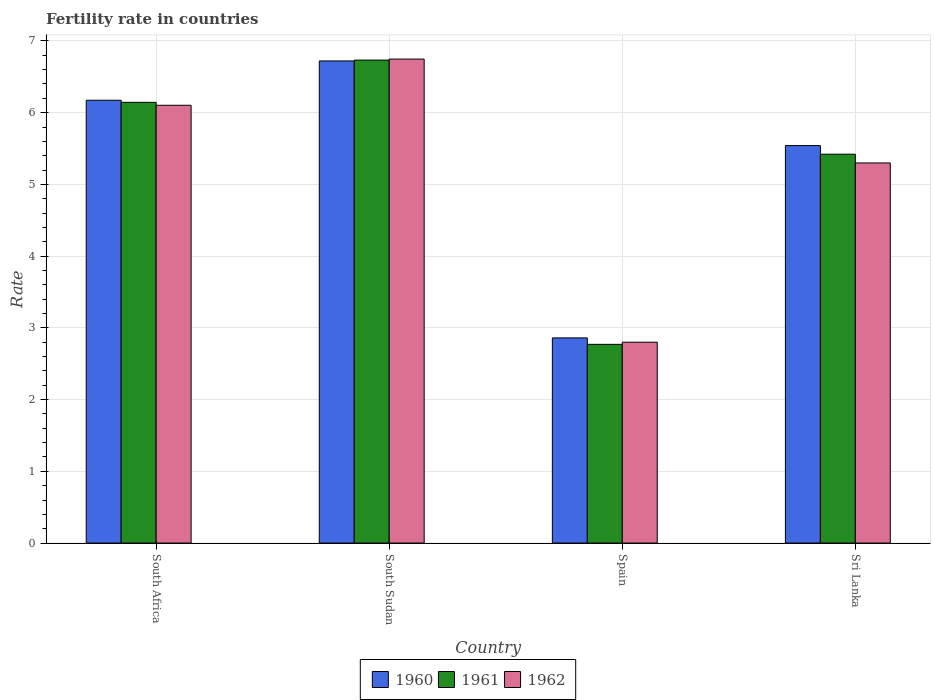How many groups of bars are there?
Keep it short and to the point. 4. Are the number of bars on each tick of the X-axis equal?
Your answer should be very brief. Yes. How many bars are there on the 4th tick from the left?
Keep it short and to the point. 3. How many bars are there on the 1st tick from the right?
Make the answer very short. 3. What is the label of the 1st group of bars from the left?
Your answer should be very brief. South Africa. What is the fertility rate in 1961 in Spain?
Your answer should be compact. 2.77. Across all countries, what is the maximum fertility rate in 1960?
Provide a short and direct response. 6.72. In which country was the fertility rate in 1962 maximum?
Provide a short and direct response. South Sudan. In which country was the fertility rate in 1960 minimum?
Give a very brief answer. Spain. What is the total fertility rate in 1961 in the graph?
Provide a short and direct response. 21.07. What is the difference between the fertility rate in 1960 in South Africa and that in Sri Lanka?
Provide a succinct answer. 0.63. What is the difference between the fertility rate in 1962 in South Africa and the fertility rate in 1961 in Sri Lanka?
Give a very brief answer. 0.68. What is the average fertility rate in 1962 per country?
Keep it short and to the point. 5.24. What is the difference between the fertility rate of/in 1960 and fertility rate of/in 1962 in Spain?
Offer a very short reply. 0.06. What is the ratio of the fertility rate in 1961 in South Africa to that in South Sudan?
Offer a very short reply. 0.91. Is the fertility rate in 1961 in South Africa less than that in Sri Lanka?
Your response must be concise. No. Is the difference between the fertility rate in 1960 in South Sudan and Sri Lanka greater than the difference between the fertility rate in 1962 in South Sudan and Sri Lanka?
Your response must be concise. No. What is the difference between the highest and the second highest fertility rate in 1961?
Provide a short and direct response. -1.31. What is the difference between the highest and the lowest fertility rate in 1961?
Ensure brevity in your answer.  3.96. In how many countries, is the fertility rate in 1962 greater than the average fertility rate in 1962 taken over all countries?
Keep it short and to the point. 3. What does the 3rd bar from the right in South Africa represents?
Give a very brief answer. 1960. Is it the case that in every country, the sum of the fertility rate in 1960 and fertility rate in 1962 is greater than the fertility rate in 1961?
Your response must be concise. Yes. What is the difference between two consecutive major ticks on the Y-axis?
Make the answer very short. 1. Are the values on the major ticks of Y-axis written in scientific E-notation?
Your answer should be very brief. No. Does the graph contain any zero values?
Offer a very short reply. No. How many legend labels are there?
Your response must be concise. 3. What is the title of the graph?
Your answer should be very brief. Fertility rate in countries. Does "2004" appear as one of the legend labels in the graph?
Keep it short and to the point. No. What is the label or title of the Y-axis?
Provide a succinct answer. Rate. What is the Rate in 1960 in South Africa?
Keep it short and to the point. 6.17. What is the Rate of 1961 in South Africa?
Your answer should be very brief. 6.14. What is the Rate in 1962 in South Africa?
Your answer should be very brief. 6.1. What is the Rate in 1960 in South Sudan?
Provide a short and direct response. 6.72. What is the Rate of 1961 in South Sudan?
Ensure brevity in your answer.  6.73. What is the Rate of 1962 in South Sudan?
Offer a very short reply. 6.75. What is the Rate of 1960 in Spain?
Offer a terse response. 2.86. What is the Rate of 1961 in Spain?
Offer a terse response. 2.77. What is the Rate in 1962 in Spain?
Offer a terse response. 2.8. What is the Rate of 1960 in Sri Lanka?
Offer a very short reply. 5.54. What is the Rate of 1961 in Sri Lanka?
Your answer should be compact. 5.42. What is the Rate in 1962 in Sri Lanka?
Your response must be concise. 5.3. Across all countries, what is the maximum Rate in 1960?
Give a very brief answer. 6.72. Across all countries, what is the maximum Rate in 1961?
Keep it short and to the point. 6.73. Across all countries, what is the maximum Rate in 1962?
Your response must be concise. 6.75. Across all countries, what is the minimum Rate of 1960?
Offer a very short reply. 2.86. Across all countries, what is the minimum Rate in 1961?
Your response must be concise. 2.77. Across all countries, what is the minimum Rate of 1962?
Your response must be concise. 2.8. What is the total Rate in 1960 in the graph?
Your answer should be very brief. 21.3. What is the total Rate in 1961 in the graph?
Give a very brief answer. 21.07. What is the total Rate in 1962 in the graph?
Offer a very short reply. 20.95. What is the difference between the Rate in 1960 in South Africa and that in South Sudan?
Offer a very short reply. -0.55. What is the difference between the Rate in 1961 in South Africa and that in South Sudan?
Make the answer very short. -0.59. What is the difference between the Rate of 1962 in South Africa and that in South Sudan?
Your answer should be very brief. -0.64. What is the difference between the Rate in 1960 in South Africa and that in Spain?
Your answer should be very brief. 3.31. What is the difference between the Rate of 1961 in South Africa and that in Spain?
Ensure brevity in your answer.  3.37. What is the difference between the Rate of 1962 in South Africa and that in Spain?
Give a very brief answer. 3.3. What is the difference between the Rate in 1960 in South Africa and that in Sri Lanka?
Offer a very short reply. 0.63. What is the difference between the Rate of 1961 in South Africa and that in Sri Lanka?
Your answer should be compact. 0.72. What is the difference between the Rate in 1962 in South Africa and that in Sri Lanka?
Your response must be concise. 0.8. What is the difference between the Rate in 1960 in South Sudan and that in Spain?
Your answer should be very brief. 3.86. What is the difference between the Rate of 1961 in South Sudan and that in Spain?
Your response must be concise. 3.96. What is the difference between the Rate of 1962 in South Sudan and that in Spain?
Ensure brevity in your answer.  3.95. What is the difference between the Rate of 1960 in South Sudan and that in Sri Lanka?
Your answer should be very brief. 1.18. What is the difference between the Rate of 1961 in South Sudan and that in Sri Lanka?
Your answer should be compact. 1.31. What is the difference between the Rate in 1962 in South Sudan and that in Sri Lanka?
Offer a terse response. 1.45. What is the difference between the Rate in 1960 in Spain and that in Sri Lanka?
Ensure brevity in your answer.  -2.68. What is the difference between the Rate of 1961 in Spain and that in Sri Lanka?
Your response must be concise. -2.65. What is the difference between the Rate of 1962 in Spain and that in Sri Lanka?
Your answer should be very brief. -2.5. What is the difference between the Rate of 1960 in South Africa and the Rate of 1961 in South Sudan?
Provide a succinct answer. -0.56. What is the difference between the Rate of 1960 in South Africa and the Rate of 1962 in South Sudan?
Offer a very short reply. -0.57. What is the difference between the Rate of 1961 in South Africa and the Rate of 1962 in South Sudan?
Your answer should be compact. -0.6. What is the difference between the Rate in 1960 in South Africa and the Rate in 1961 in Spain?
Your response must be concise. 3.4. What is the difference between the Rate in 1960 in South Africa and the Rate in 1962 in Spain?
Your response must be concise. 3.37. What is the difference between the Rate of 1961 in South Africa and the Rate of 1962 in Spain?
Offer a terse response. 3.34. What is the difference between the Rate of 1960 in South Africa and the Rate of 1961 in Sri Lanka?
Your answer should be very brief. 0.75. What is the difference between the Rate in 1960 in South Africa and the Rate in 1962 in Sri Lanka?
Provide a succinct answer. 0.87. What is the difference between the Rate of 1961 in South Africa and the Rate of 1962 in Sri Lanka?
Give a very brief answer. 0.84. What is the difference between the Rate of 1960 in South Sudan and the Rate of 1961 in Spain?
Make the answer very short. 3.95. What is the difference between the Rate of 1960 in South Sudan and the Rate of 1962 in Spain?
Your answer should be compact. 3.92. What is the difference between the Rate in 1961 in South Sudan and the Rate in 1962 in Spain?
Your answer should be compact. 3.93. What is the difference between the Rate in 1960 in South Sudan and the Rate in 1962 in Sri Lanka?
Offer a terse response. 1.42. What is the difference between the Rate in 1961 in South Sudan and the Rate in 1962 in Sri Lanka?
Make the answer very short. 1.43. What is the difference between the Rate of 1960 in Spain and the Rate of 1961 in Sri Lanka?
Make the answer very short. -2.56. What is the difference between the Rate of 1960 in Spain and the Rate of 1962 in Sri Lanka?
Your response must be concise. -2.44. What is the difference between the Rate of 1961 in Spain and the Rate of 1962 in Sri Lanka?
Provide a short and direct response. -2.53. What is the average Rate in 1960 per country?
Provide a succinct answer. 5.32. What is the average Rate of 1961 per country?
Give a very brief answer. 5.27. What is the average Rate in 1962 per country?
Provide a succinct answer. 5.24. What is the difference between the Rate in 1960 and Rate in 1961 in South Africa?
Provide a succinct answer. 0.03. What is the difference between the Rate in 1960 and Rate in 1962 in South Africa?
Your response must be concise. 0.07. What is the difference between the Rate in 1961 and Rate in 1962 in South Africa?
Make the answer very short. 0.04. What is the difference between the Rate of 1960 and Rate of 1961 in South Sudan?
Keep it short and to the point. -0.01. What is the difference between the Rate in 1960 and Rate in 1962 in South Sudan?
Your response must be concise. -0.03. What is the difference between the Rate in 1961 and Rate in 1962 in South Sudan?
Make the answer very short. -0.01. What is the difference between the Rate in 1960 and Rate in 1961 in Spain?
Offer a very short reply. 0.09. What is the difference between the Rate in 1960 and Rate in 1962 in Spain?
Your answer should be very brief. 0.06. What is the difference between the Rate of 1961 and Rate of 1962 in Spain?
Make the answer very short. -0.03. What is the difference between the Rate of 1960 and Rate of 1961 in Sri Lanka?
Offer a very short reply. 0.12. What is the difference between the Rate of 1960 and Rate of 1962 in Sri Lanka?
Provide a succinct answer. 0.24. What is the difference between the Rate of 1961 and Rate of 1962 in Sri Lanka?
Offer a terse response. 0.12. What is the ratio of the Rate of 1960 in South Africa to that in South Sudan?
Your answer should be very brief. 0.92. What is the ratio of the Rate of 1961 in South Africa to that in South Sudan?
Your response must be concise. 0.91. What is the ratio of the Rate of 1962 in South Africa to that in South Sudan?
Ensure brevity in your answer.  0.9. What is the ratio of the Rate in 1960 in South Africa to that in Spain?
Your answer should be compact. 2.16. What is the ratio of the Rate of 1961 in South Africa to that in Spain?
Offer a terse response. 2.22. What is the ratio of the Rate of 1962 in South Africa to that in Spain?
Make the answer very short. 2.18. What is the ratio of the Rate in 1960 in South Africa to that in Sri Lanka?
Give a very brief answer. 1.11. What is the ratio of the Rate of 1961 in South Africa to that in Sri Lanka?
Provide a short and direct response. 1.13. What is the ratio of the Rate of 1962 in South Africa to that in Sri Lanka?
Ensure brevity in your answer.  1.15. What is the ratio of the Rate of 1960 in South Sudan to that in Spain?
Offer a terse response. 2.35. What is the ratio of the Rate of 1961 in South Sudan to that in Spain?
Offer a very short reply. 2.43. What is the ratio of the Rate of 1962 in South Sudan to that in Spain?
Your response must be concise. 2.41. What is the ratio of the Rate in 1960 in South Sudan to that in Sri Lanka?
Keep it short and to the point. 1.21. What is the ratio of the Rate of 1961 in South Sudan to that in Sri Lanka?
Your response must be concise. 1.24. What is the ratio of the Rate in 1962 in South Sudan to that in Sri Lanka?
Offer a terse response. 1.27. What is the ratio of the Rate of 1960 in Spain to that in Sri Lanka?
Make the answer very short. 0.52. What is the ratio of the Rate in 1961 in Spain to that in Sri Lanka?
Give a very brief answer. 0.51. What is the ratio of the Rate in 1962 in Spain to that in Sri Lanka?
Offer a terse response. 0.53. What is the difference between the highest and the second highest Rate of 1960?
Provide a short and direct response. 0.55. What is the difference between the highest and the second highest Rate in 1961?
Offer a very short reply. 0.59. What is the difference between the highest and the second highest Rate in 1962?
Your answer should be very brief. 0.64. What is the difference between the highest and the lowest Rate of 1960?
Offer a terse response. 3.86. What is the difference between the highest and the lowest Rate of 1961?
Your answer should be compact. 3.96. What is the difference between the highest and the lowest Rate in 1962?
Your answer should be very brief. 3.95. 